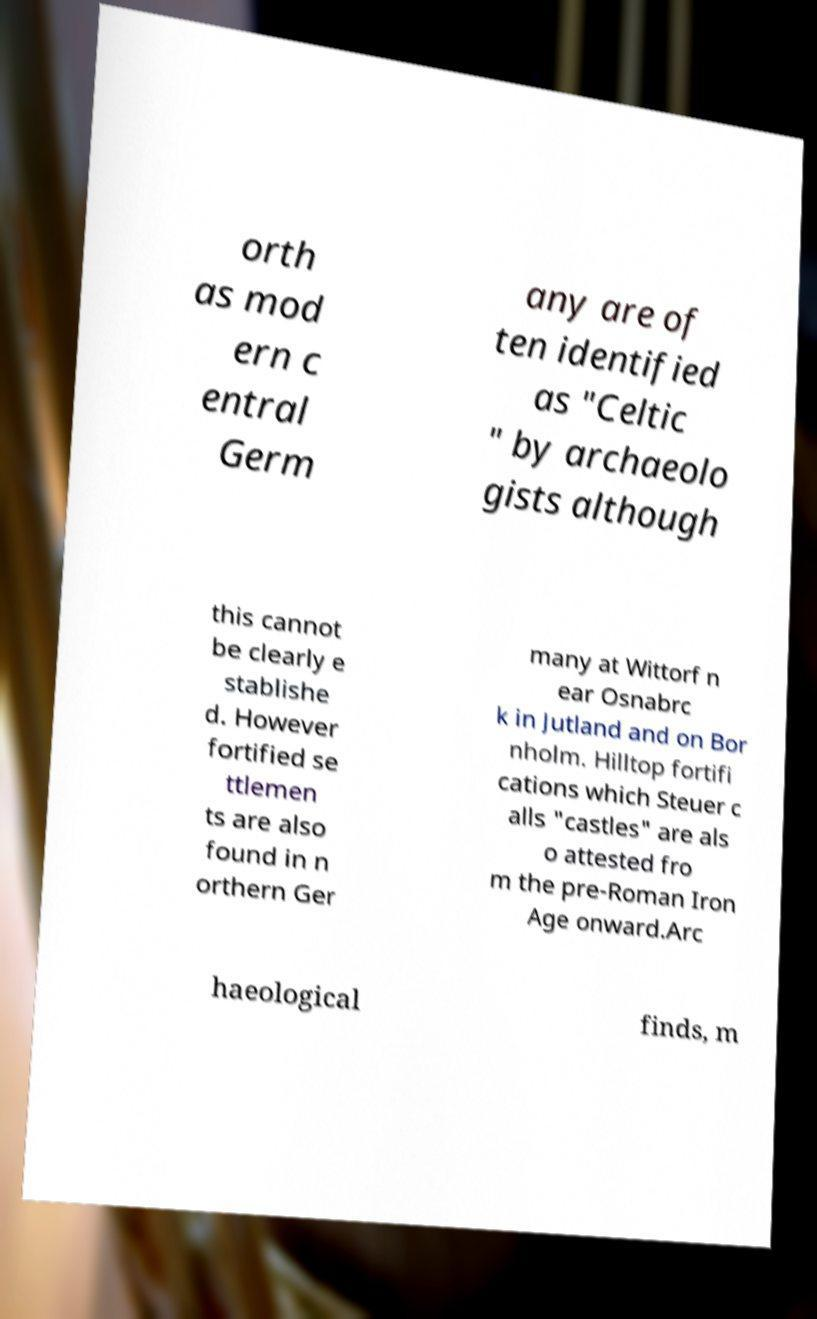I need the written content from this picture converted into text. Can you do that? orth as mod ern c entral Germ any are of ten identified as "Celtic " by archaeolo gists although this cannot be clearly e stablishe d. However fortified se ttlemen ts are also found in n orthern Ger many at Wittorf n ear Osnabrc k in Jutland and on Bor nholm. Hilltop fortifi cations which Steuer c alls "castles" are als o attested fro m the pre-Roman Iron Age onward.Arc haeological finds, m 